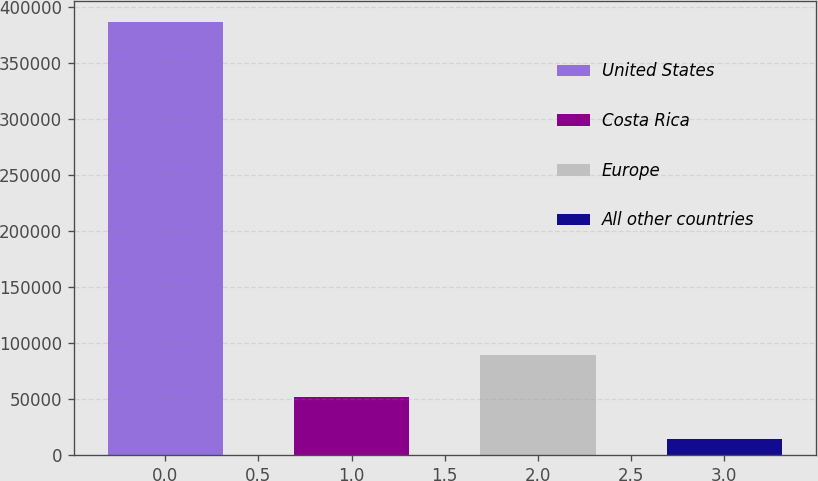<chart> <loc_0><loc_0><loc_500><loc_500><bar_chart><fcel>United States<fcel>Costa Rica<fcel>Europe<fcel>All other countries<nl><fcel>386049<fcel>51879<fcel>89009<fcel>14749<nl></chart> 